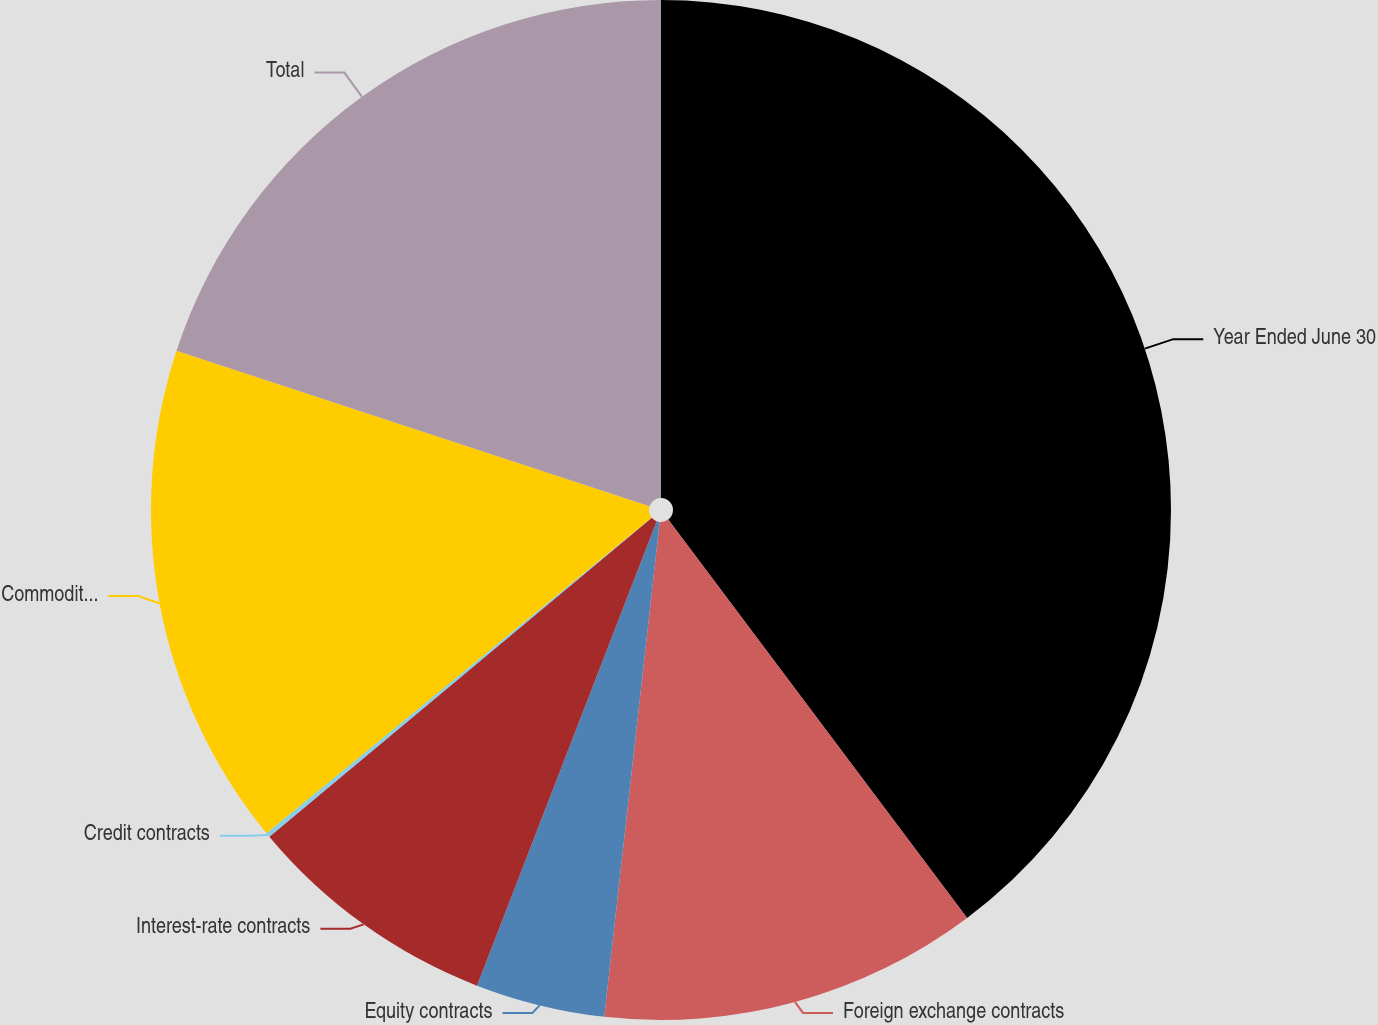Convert chart to OTSL. <chart><loc_0><loc_0><loc_500><loc_500><pie_chart><fcel>Year Ended June 30<fcel>Foreign exchange contracts<fcel>Equity contracts<fcel>Interest-rate contracts<fcel>Credit contracts<fcel>Commodity contracts<fcel>Total<nl><fcel>39.75%<fcel>12.02%<fcel>4.1%<fcel>8.06%<fcel>0.14%<fcel>15.98%<fcel>19.94%<nl></chart> 